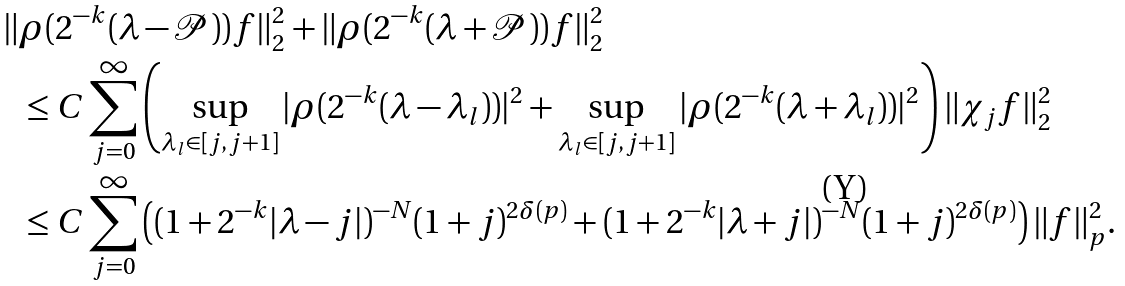<formula> <loc_0><loc_0><loc_500><loc_500>\| & \rho ( 2 ^ { - k } ( \lambda - \mathcal { P } ) ) f \| _ { 2 } ^ { 2 } + \| \rho ( 2 ^ { - k } ( \lambda + \mathcal { P } ) ) f \| _ { 2 } ^ { 2 } \\ & \leq C \sum _ { j = 0 } ^ { \infty } \left ( \sup _ { \lambda _ { l } \in [ j , j + 1 ] } | \rho ( 2 ^ { - k } ( \lambda - \lambda _ { l } ) ) | ^ { 2 } + \sup _ { \lambda _ { l } \in [ j , j + 1 ] } | \rho ( 2 ^ { - k } ( \lambda + \lambda _ { l } ) ) | ^ { 2 } \right ) \| \chi _ { j } f \| _ { 2 } ^ { 2 } \\ & \leq C \sum _ { j = 0 } ^ { \infty } \left ( ( 1 + 2 ^ { - k } | \lambda - j | ) ^ { - N } ( 1 + j ) ^ { 2 \delta ( p ) } + ( 1 + 2 ^ { - k } | \lambda + j | ) ^ { - N } ( 1 + j ) ^ { 2 \delta ( p ) } \right ) \| f \| _ { p } ^ { 2 } .</formula> 